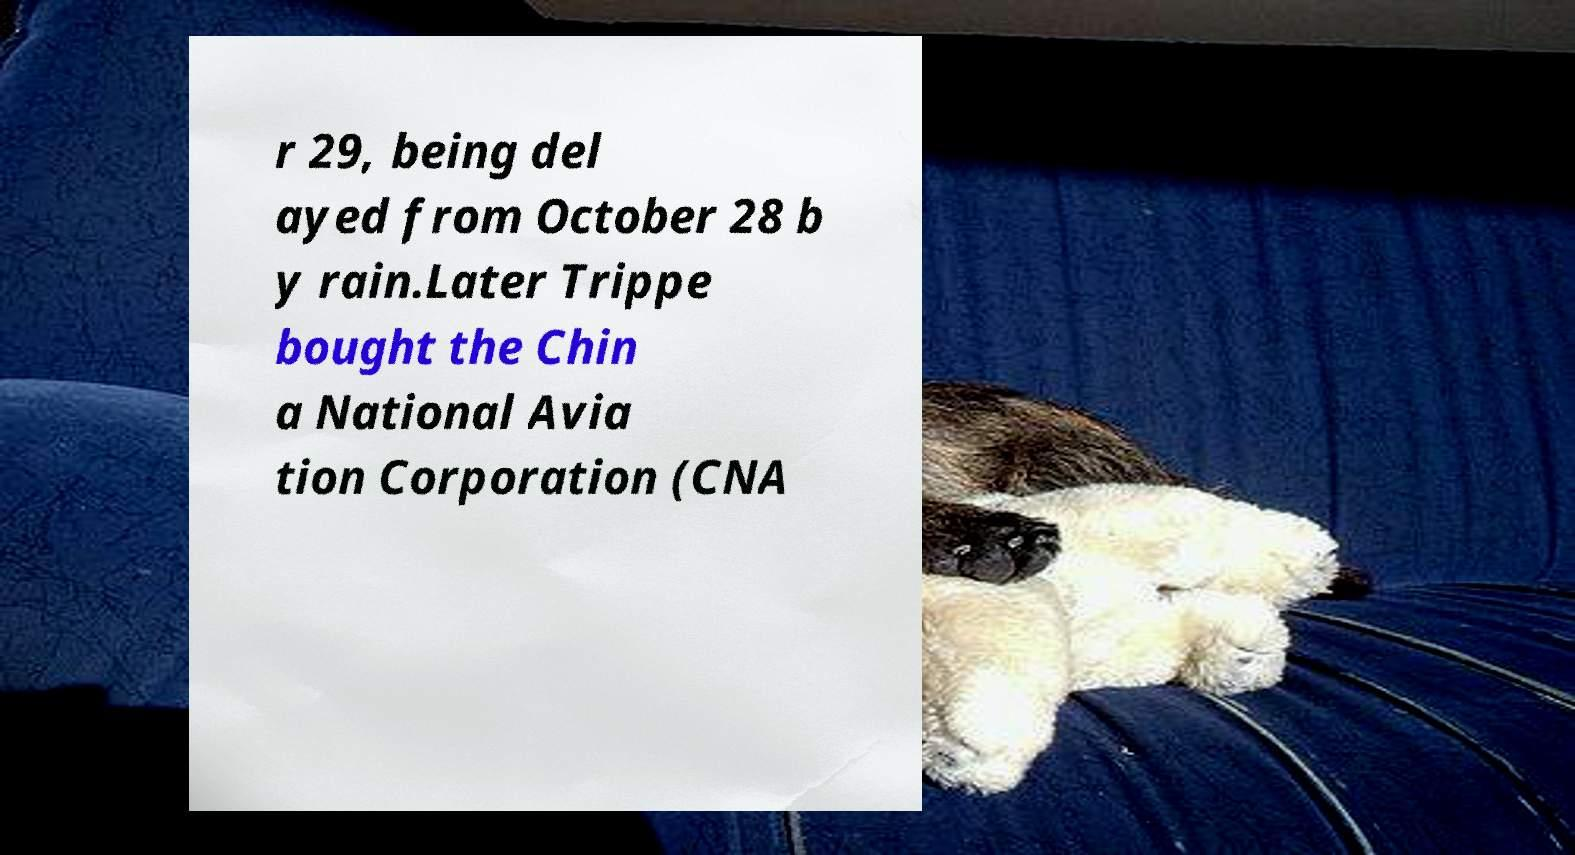For documentation purposes, I need the text within this image transcribed. Could you provide that? r 29, being del ayed from October 28 b y rain.Later Trippe bought the Chin a National Avia tion Corporation (CNA 